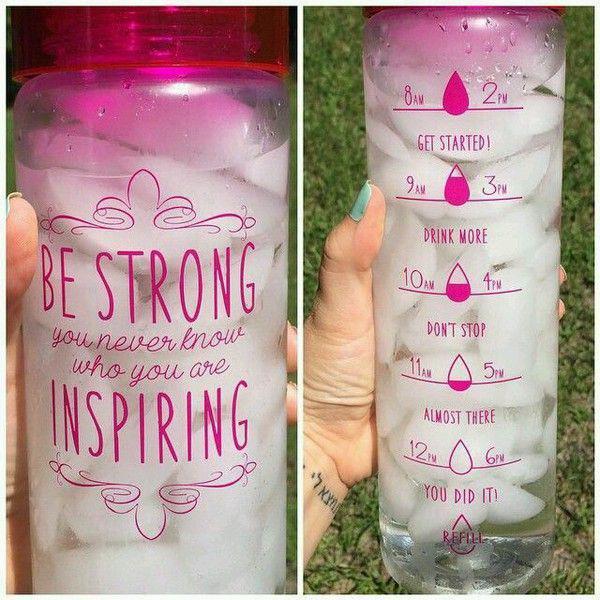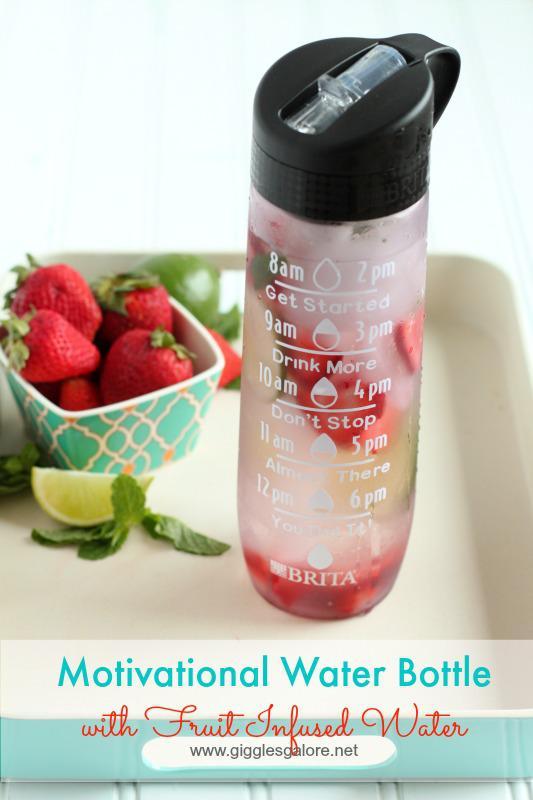The first image is the image on the left, the second image is the image on the right. Examine the images to the left and right. Is the description "In one of the images, four water bottles with carrying straps are sitting in a row on a table." accurate? Answer yes or no. No. The first image is the image on the left, the second image is the image on the right. Considering the images on both sides, is "One image features a horizontal row of four water bottles with straps on them and different designs on their fronts." valid? Answer yes or no. No. 